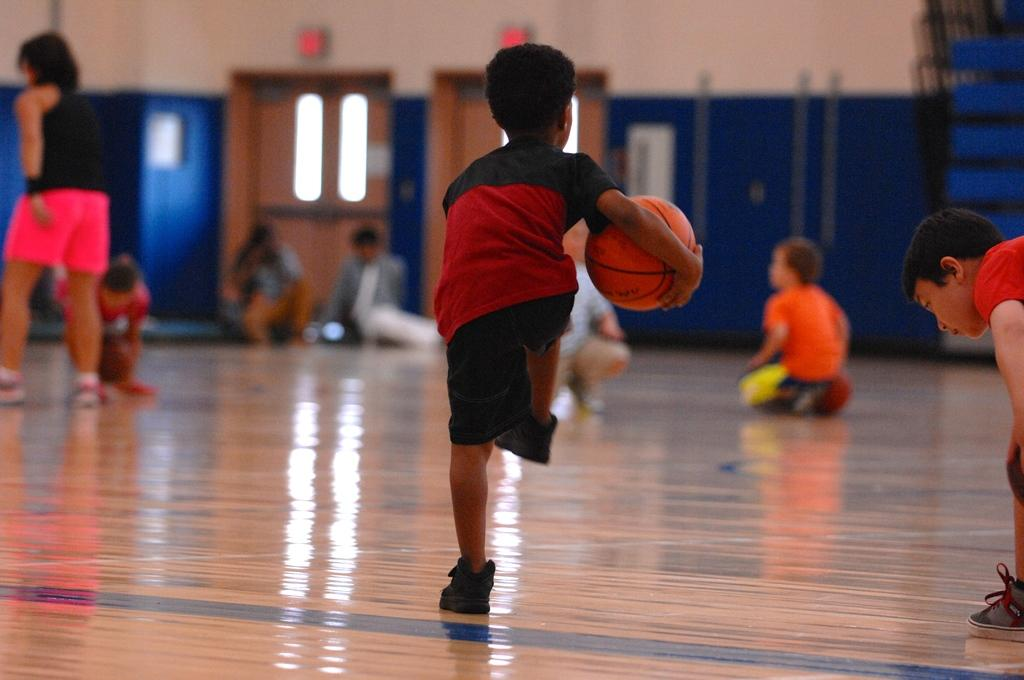What is the boy in the image holding? The boy is holding a basketball. What are the other people in the image doing? The group of people in the image is not specified, so we cannot determine their actions. What type of architectural feature can be seen in the image? There are doors and a wall visible in the image. What can be seen in the background of the image? There are other objects visible in the background of the image, but their specific nature is not mentioned. What type of song is the boy singing in the image? There is no indication in the image that the boy is singing a song, so we cannot determine the type of song. 